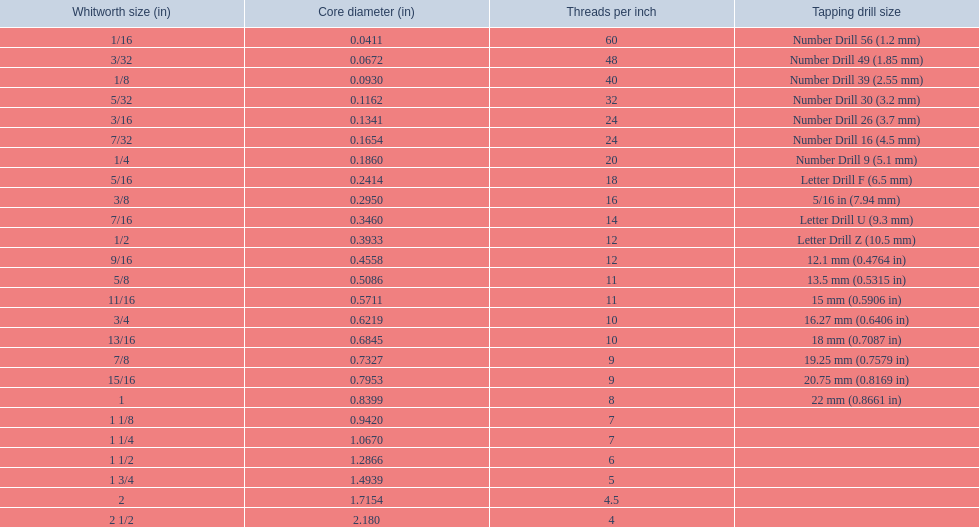What are all the whitworth sizes? 1/16, 3/32, 1/8, 5/32, 3/16, 7/32, 1/4, 5/16, 3/8, 7/16, 1/2, 9/16, 5/8, 11/16, 3/4, 13/16, 7/8, 15/16, 1, 1 1/8, 1 1/4, 1 1/2, 1 3/4, 2, 2 1/2. What are the threads per inch of these sizes? 60, 48, 40, 32, 24, 24, 20, 18, 16, 14, 12, 12, 11, 11, 10, 10, 9, 9, 8, 7, 7, 6, 5, 4.5, 4. Of these, which are 5? 5. What whitworth size has this threads per inch? 1 3/4. 